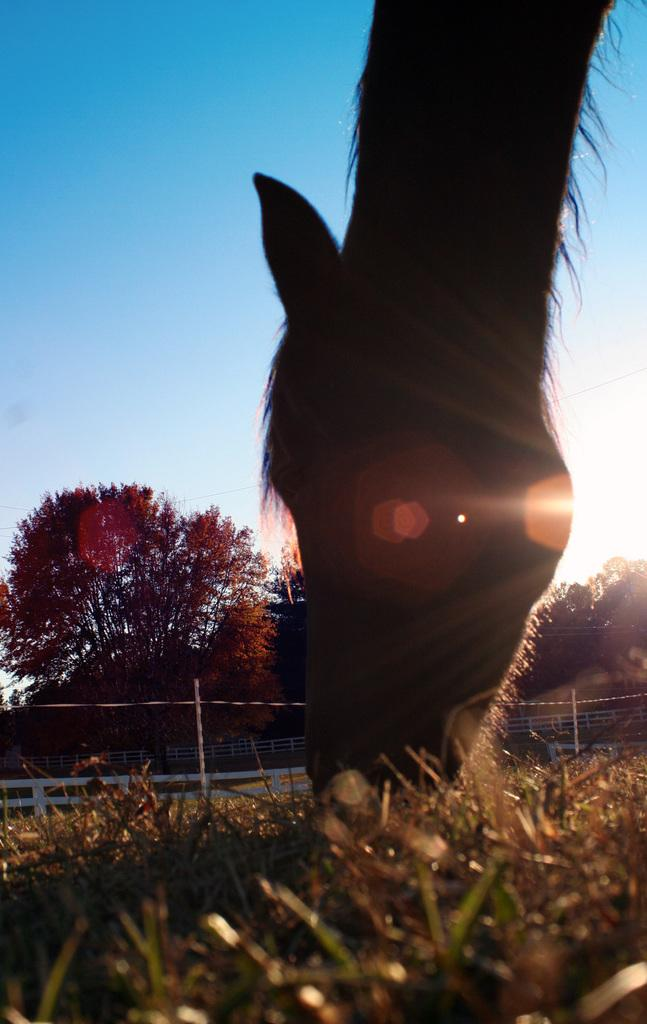What type of animal is in the image? There is an animal in the image, but the specific type cannot be determined from the provided facts. What is at the bottom of the image? There is grass at the bottom of the image. What can be seen in the background of the image? In the background of the image, there is a fence, trees, and the sky. What statement is being made by the animal in the image? There is no indication in the image that the animal is making a statement. What country is the image taken in? The provided facts do not give any information about the location of the image. 